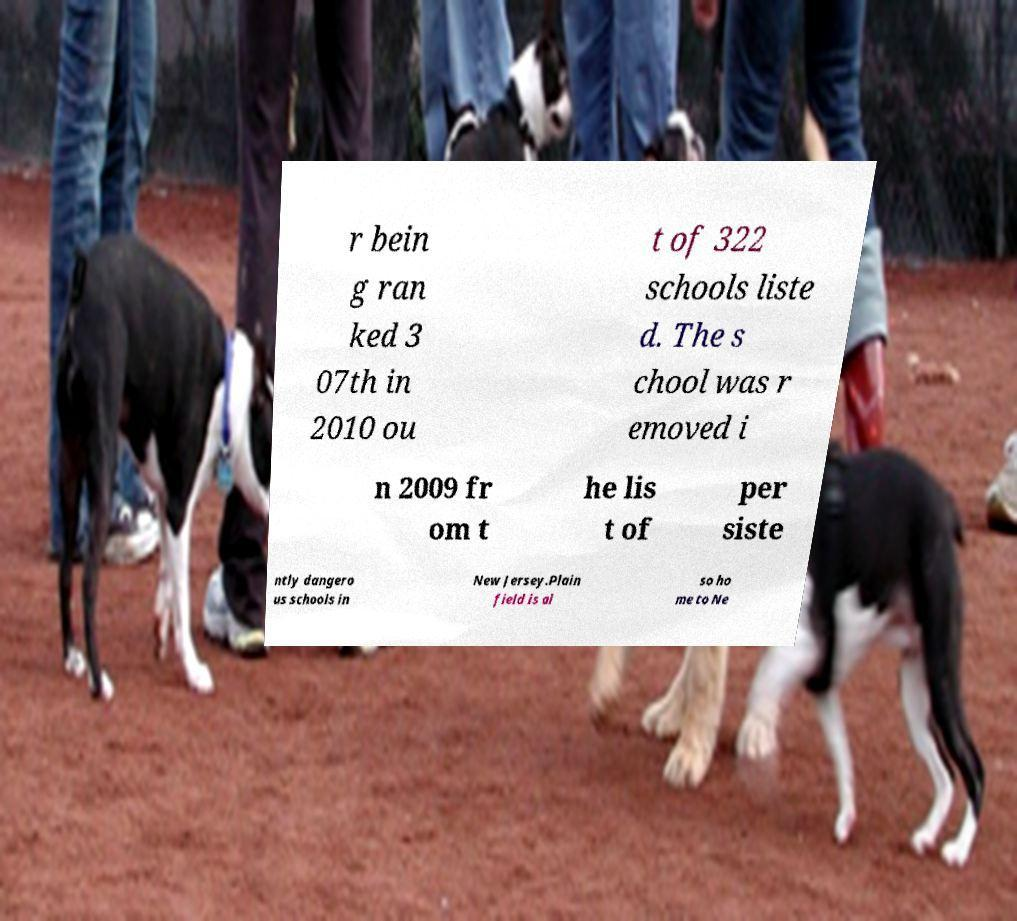Please read and relay the text visible in this image. What does it say? r bein g ran ked 3 07th in 2010 ou t of 322 schools liste d. The s chool was r emoved i n 2009 fr om t he lis t of per siste ntly dangero us schools in New Jersey.Plain field is al so ho me to Ne 